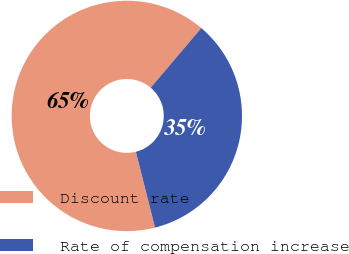Convert chart. <chart><loc_0><loc_0><loc_500><loc_500><pie_chart><fcel>Discount rate<fcel>Rate of compensation increase<nl><fcel>65.13%<fcel>34.87%<nl></chart> 